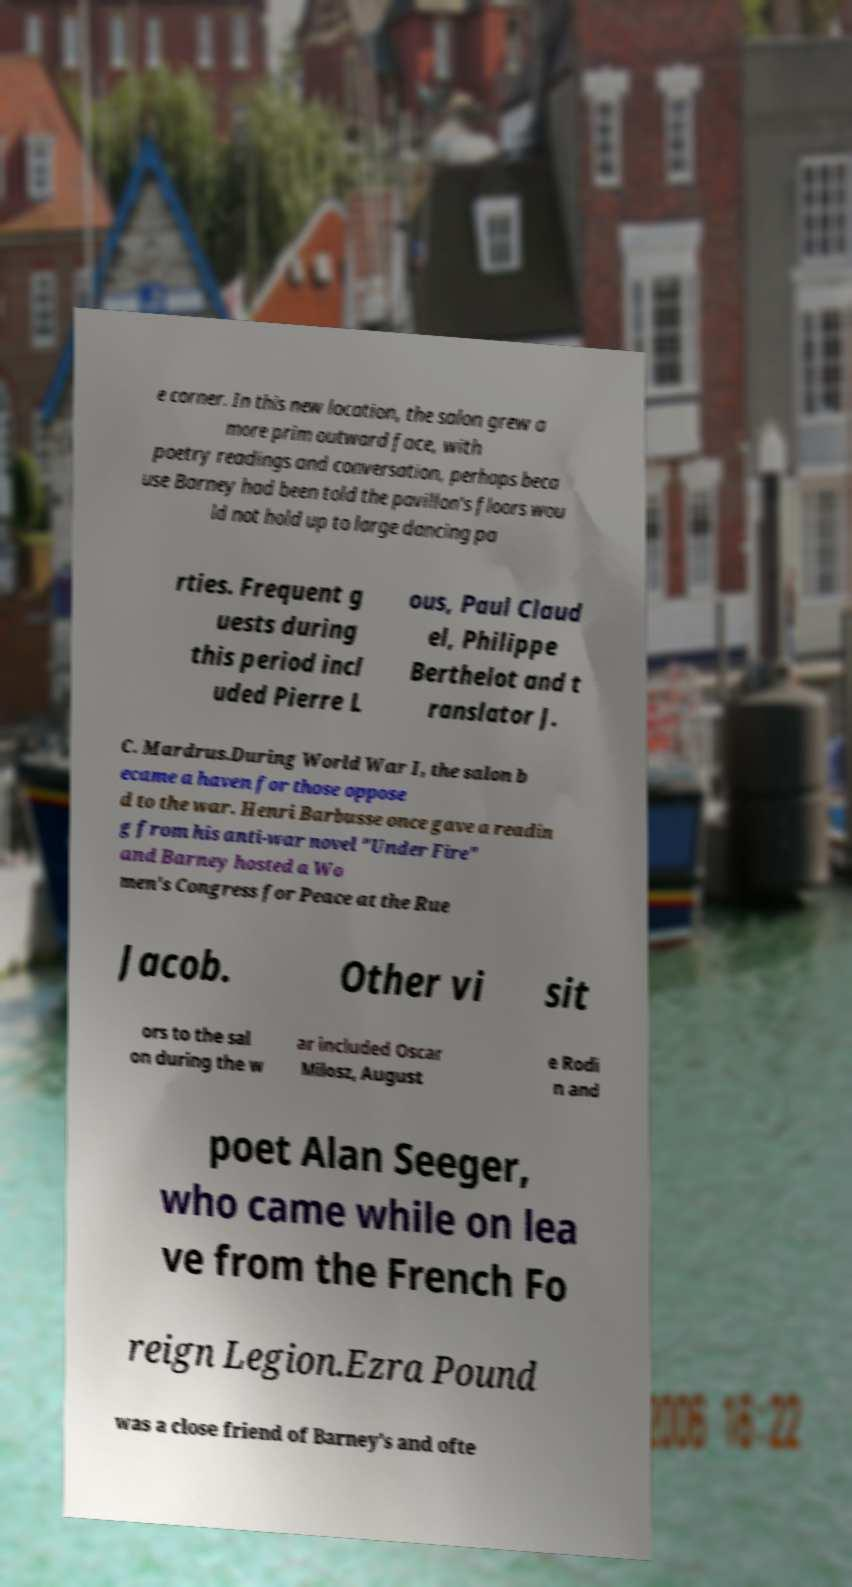There's text embedded in this image that I need extracted. Can you transcribe it verbatim? e corner. In this new location, the salon grew a more prim outward face, with poetry readings and conversation, perhaps beca use Barney had been told the pavillon's floors wou ld not hold up to large dancing pa rties. Frequent g uests during this period incl uded Pierre L ous, Paul Claud el, Philippe Berthelot and t ranslator J. C. Mardrus.During World War I, the salon b ecame a haven for those oppose d to the war. Henri Barbusse once gave a readin g from his anti-war novel "Under Fire" and Barney hosted a Wo men's Congress for Peace at the Rue Jacob. Other vi sit ors to the sal on during the w ar included Oscar Milosz, August e Rodi n and poet Alan Seeger, who came while on lea ve from the French Fo reign Legion.Ezra Pound was a close friend of Barney's and ofte 